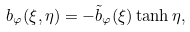Convert formula to latex. <formula><loc_0><loc_0><loc_500><loc_500>b _ { \varphi } ( \xi , \eta ) = - \tilde { b } _ { \varphi } ( \xi ) \tanh \eta ,</formula> 